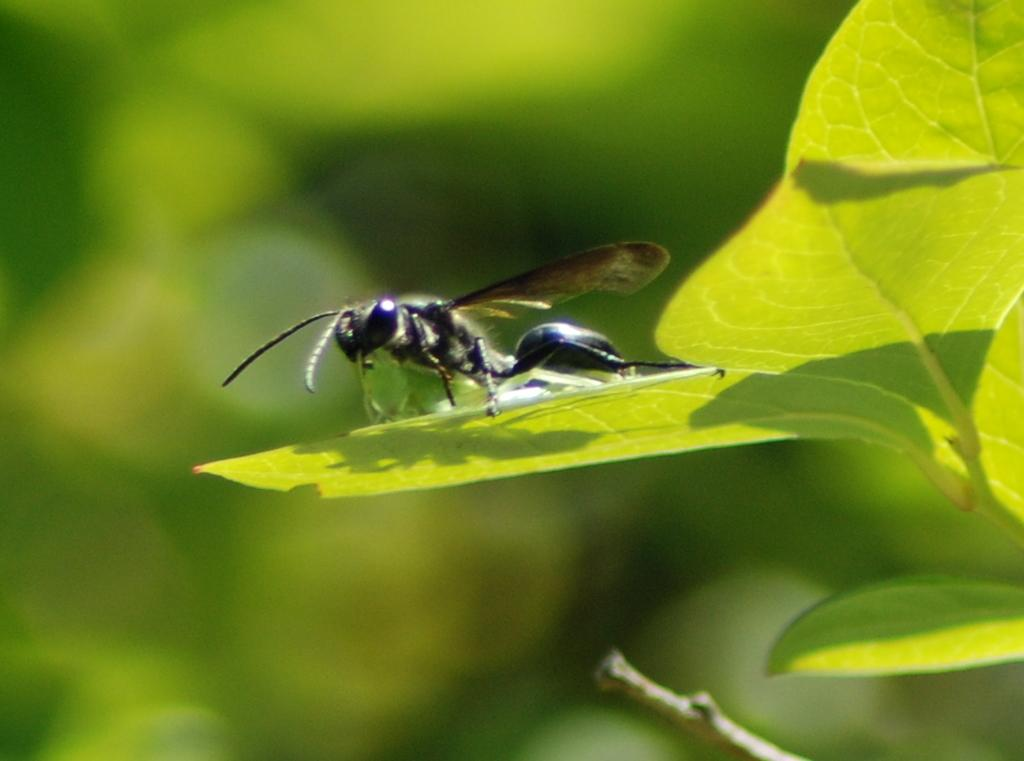What is present in the image? There is an insect in the image. Where is the insect located? The insect is on a leaf. What color is the background of the image? The background of the image is green in color. What type of dress is the insect wearing in the image? There is no dress present in the image, as insects do not wear clothing. 